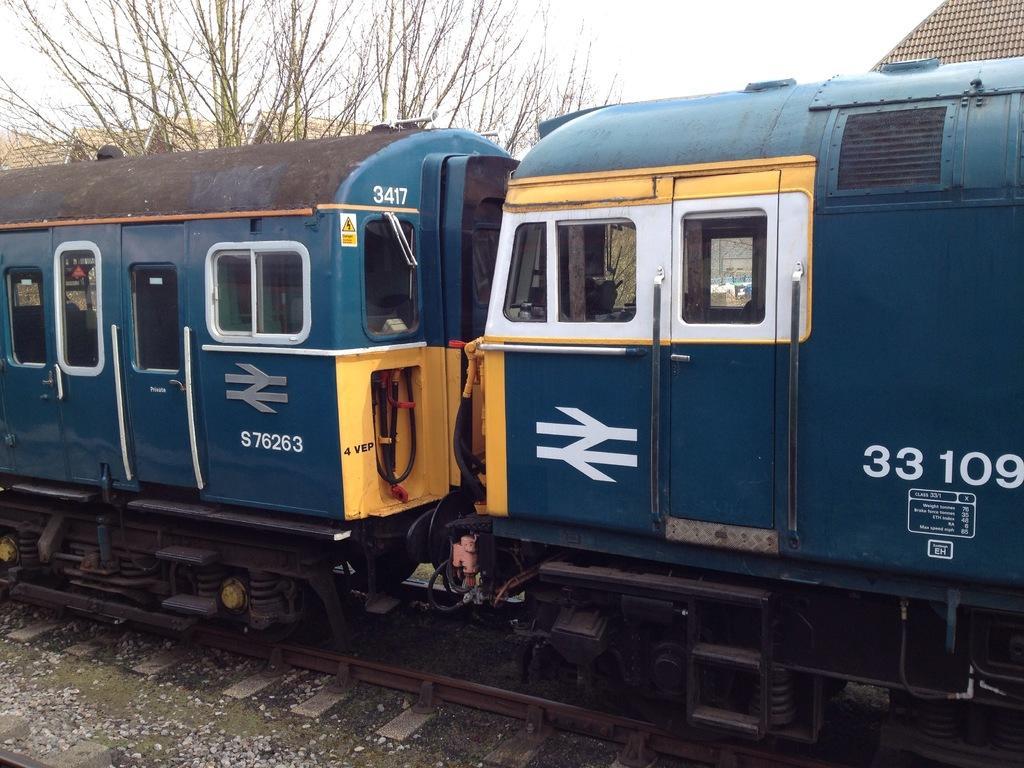Describe this image in one or two sentences. In the center of the image we can see a train. In the background of the image we can see roofs, tree. At the bottom of the image we can see railway track and some stones, ground. At the top of the image we can see the sky. 